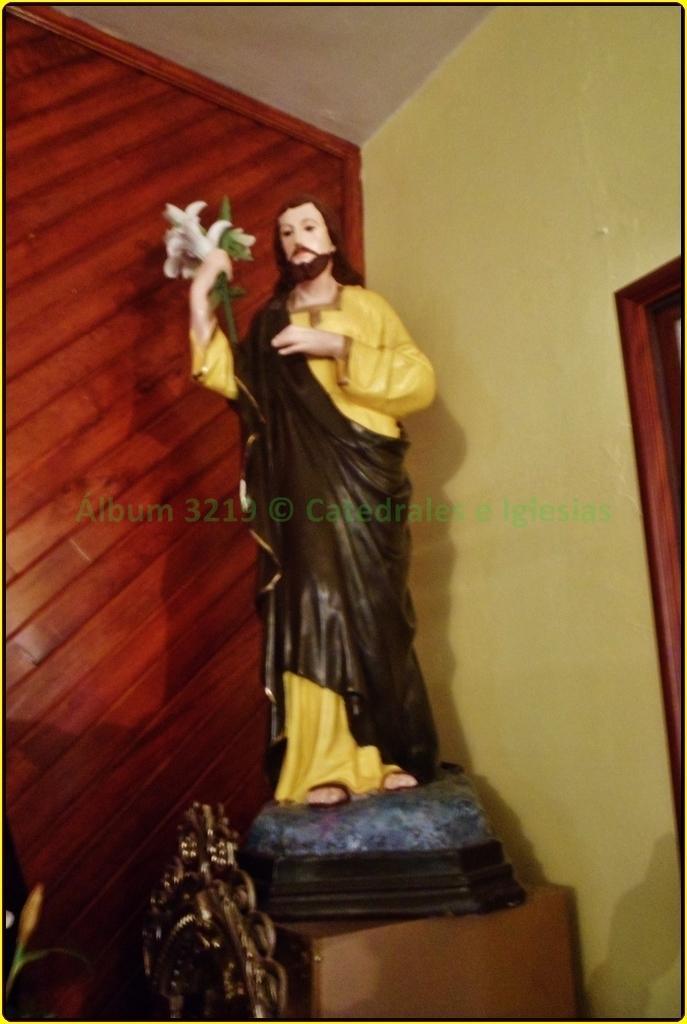How would you summarize this image in a sentence or two? In the center of the image there is a statue. In the background of the image there is wall. There is a wooden surface. At the top of the image there is ceiling. 